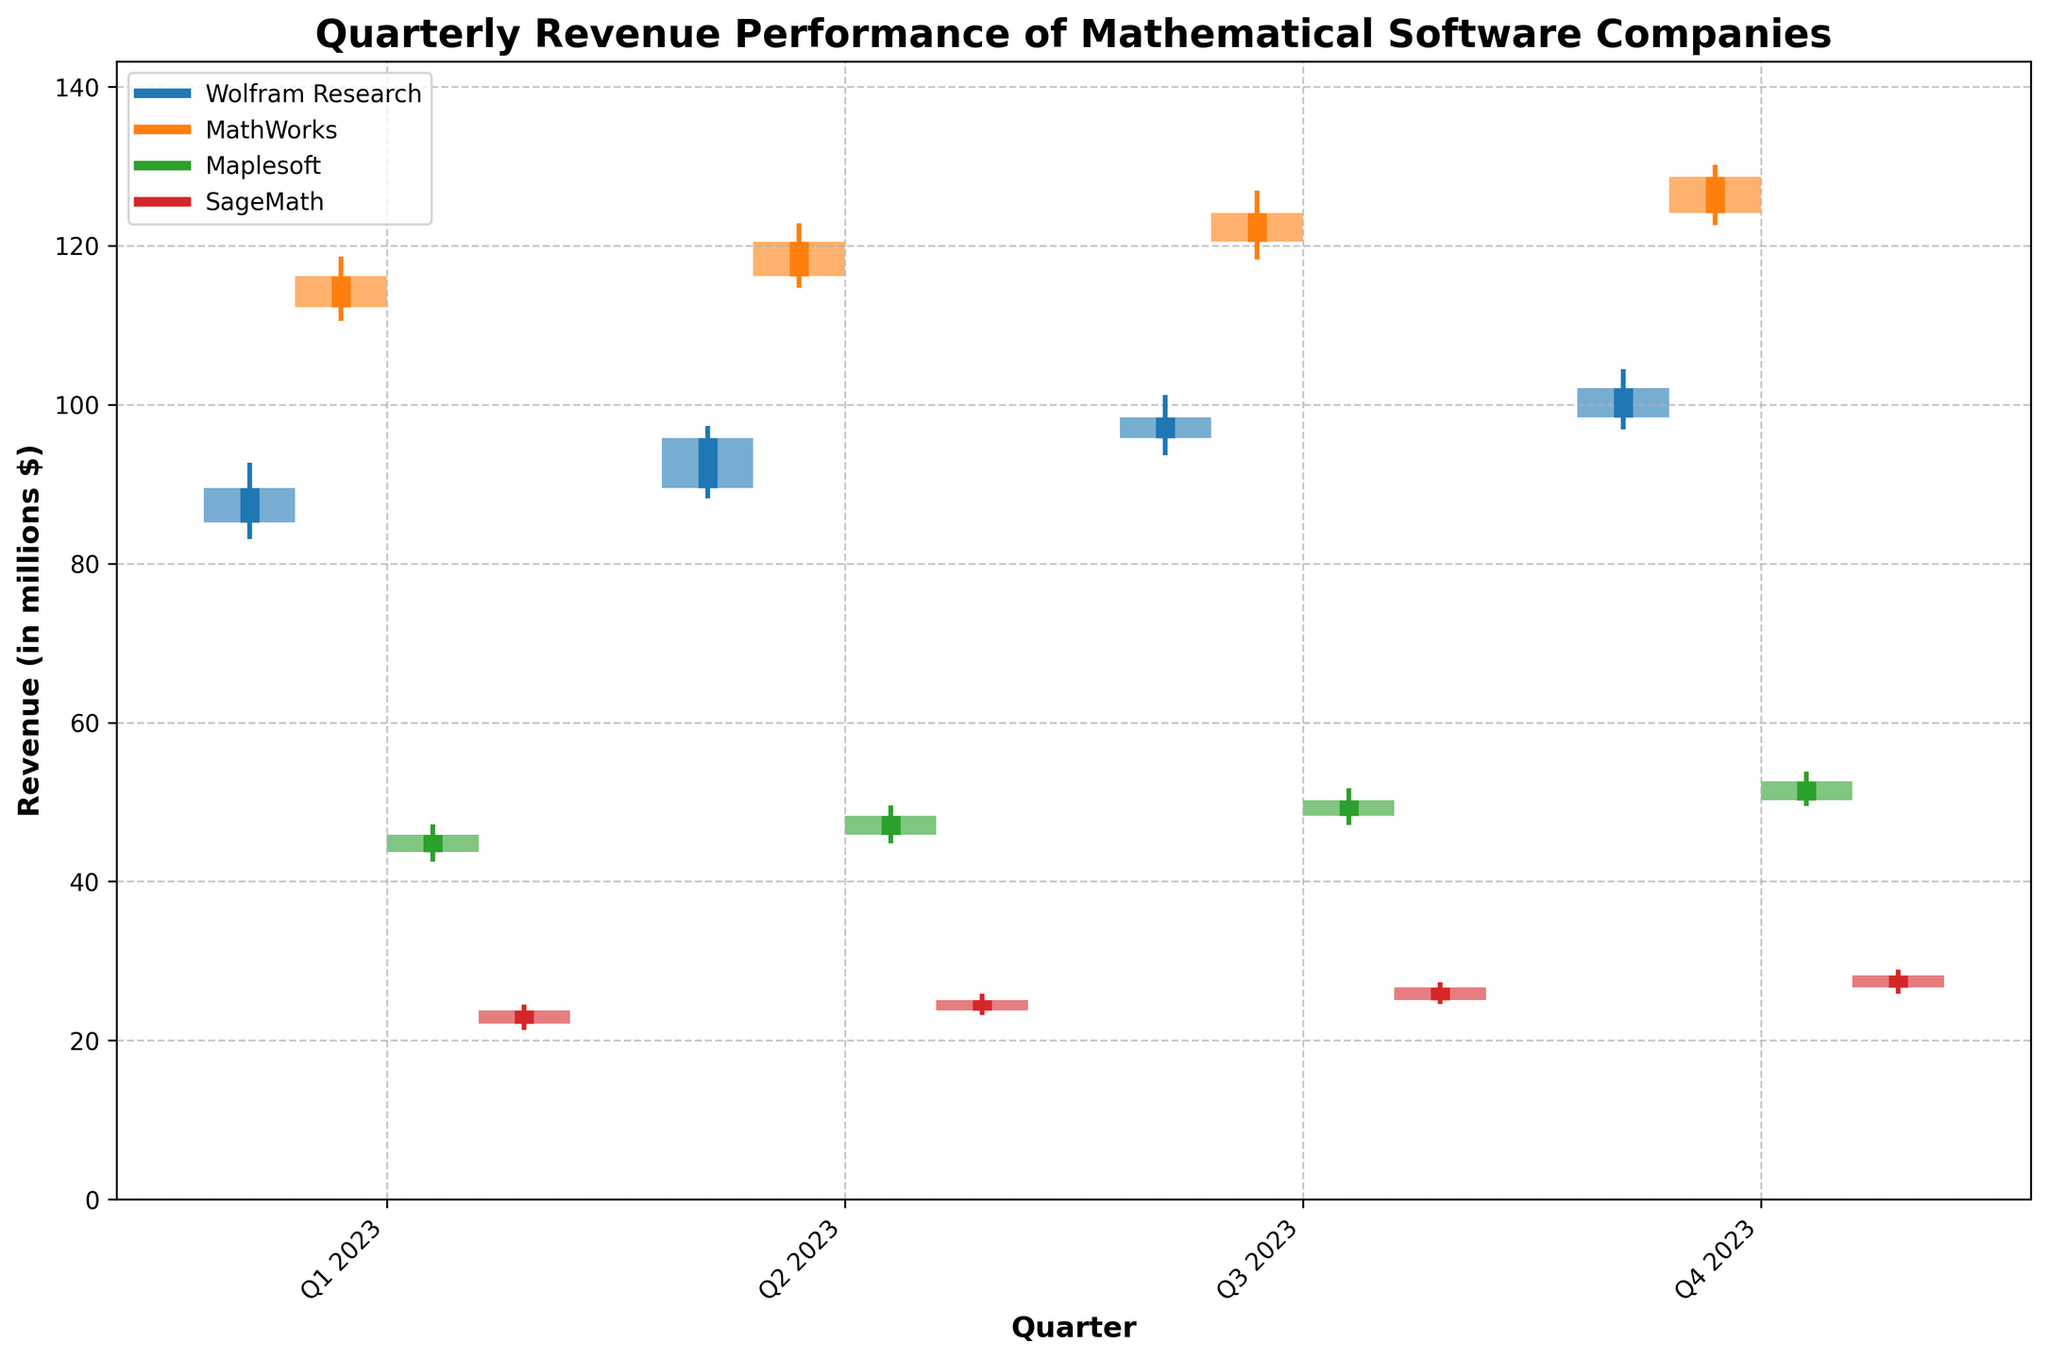Which company shows the highest high value in Q2 2023? Check the high values for each company in Q2 2023 and identify the highest one. The high values are: Wolfram Research (97.3), MathWorks (122.8), Maplesoft (49.6), SageMath (25.9). MathWorks has the highest high value of 122.8.
Answer: MathWorks Over Q1 2023 to Q4 2023, which company's close value increased the least? Calculate the difference between closing values from Q1 to Q4 2023 for each company: Wolfram Research (102.1 - 89.5 = 12.6), MathWorks (128.7 - 116.2 = 12.5), Maplesoft (52.6 - 45.9 = 6.7), SageMath (28.2 - 23.8 = 4.4). SageMath shows the smallest increase of 4.4.
Answer: SageMath What is the average closing value for Maplesoft across all quarters? Sum the closing values of Maplesoft across the four quarters and divide by 4: (45.9 + 48.3 + 50.2 + 52.6) / 4 = 197.0 / 4 = 49.25.
Answer: 49.25 Compare the highest high value and the lowest low value for all companies in Q4 2023. Which company has the highest and lowest? Identify the highest high and lowest low values for each company in Q4 2023: Wolfram Research (high 104.5, low 96.9), MathWorks (high 130.2, low 122.6), Maplesoft (high 53.8, low 49.5), SageMath (high 28.9, low 25.9). The highest high value is 130.2 by MathWorks and the lowest low value is 25.9 by SageMath.
Answer: Highest: MathWorks, Lowest: SageMath Which quarter showed the highest closing value for Wolfram Research? Look at the closing values for Wolfram Research across all quarters: Q1 2023 (89.5), Q2 2023 (95.8), Q3 2023 (98.4), Q4 2023 (102.1). The highest closing value is in Q4 2023: 102.1.
Answer: Q4 2023 Which company had the highest increase in closing value between any two consecutive quarters? Calculate the differences in closing values between consecutive quarters for each company and identify the maximum change. Wolfram Research: Q1-Q2 (89.5 to 95.8 = 6.3), Q2-Q3 (95.8 to 98.4 = 2.6), Q3-Q4 (98.4 to 102.1 = 3.7), MathWorks: Q1-Q2 (116.2 to 120.5 = 4.3), Q2-Q3 (120.5 to 124.1 = 3.6), Q3-Q4 (124.1 to 128.7 = 4.6), Maplesoft: Q1-Q2 (45.9 to 48.3 = 2.4), Q2-Q3 (48.3 to 50.2 = 1.9), Q3-Q4 (50.2 to 52.6 = 2.4), SageMath: Q1-Q2 (23.8 to 25.1 = 1.3), Q2-Q3 (25.1 to 26.7 = 1.6), Q3-Q4 (26.7 to 28.2 = 1.5). The highest increase is 6.3 for Wolfram Research from Q1 to Q2 2023.
Answer: Wolfram Research Between Q1 2023 and Q4 2023, which company had the majority of its quarters with closing values higher than the opening values? Check the closing and opening values for each company between Q1 and Q4 2023. Count the quarters where the closing value is higher than the opening value: Wolfram Research (all 4 quarters), MathWorks (all 4 quarters), Maplesoft (all 4 quarters), SageMath (all 4 quarters). All companies had closing values higher than opening values in all quarters.
Answer: All companies 